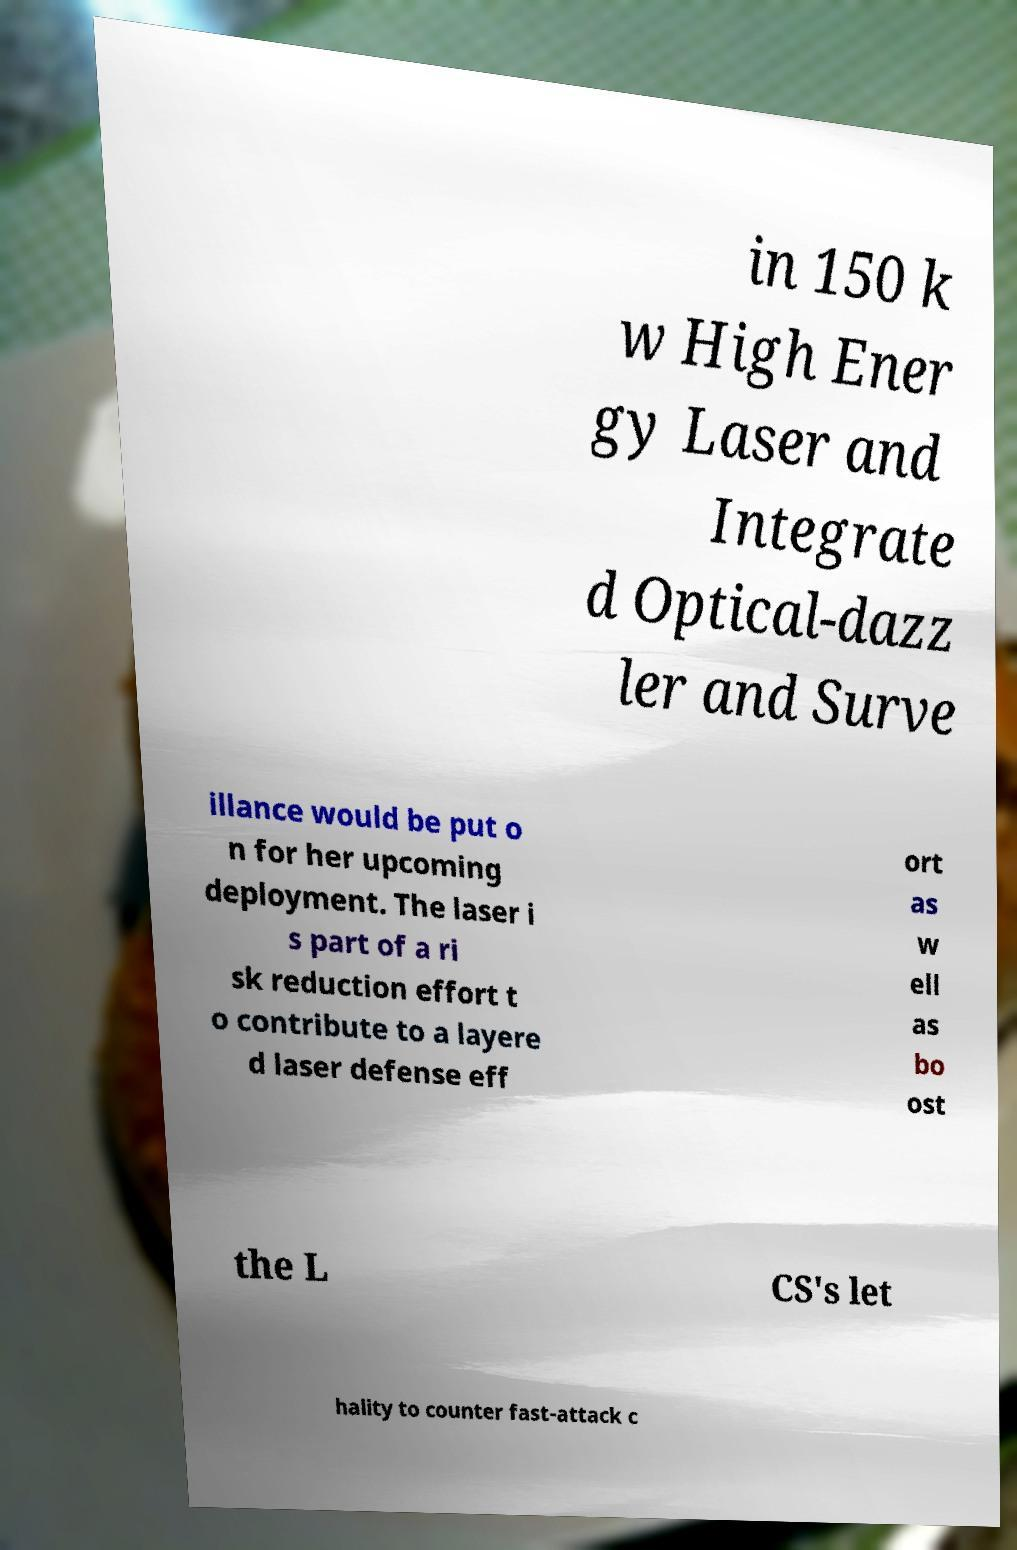Could you extract and type out the text from this image? in 150 k w High Ener gy Laser and Integrate d Optical-dazz ler and Surve illance would be put o n for her upcoming deployment. The laser i s part of a ri sk reduction effort t o contribute to a layere d laser defense eff ort as w ell as bo ost the L CS's let hality to counter fast-attack c 